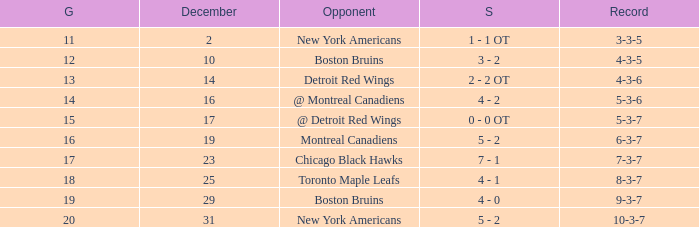Which December has a Record of 4-3-6? 14.0. 